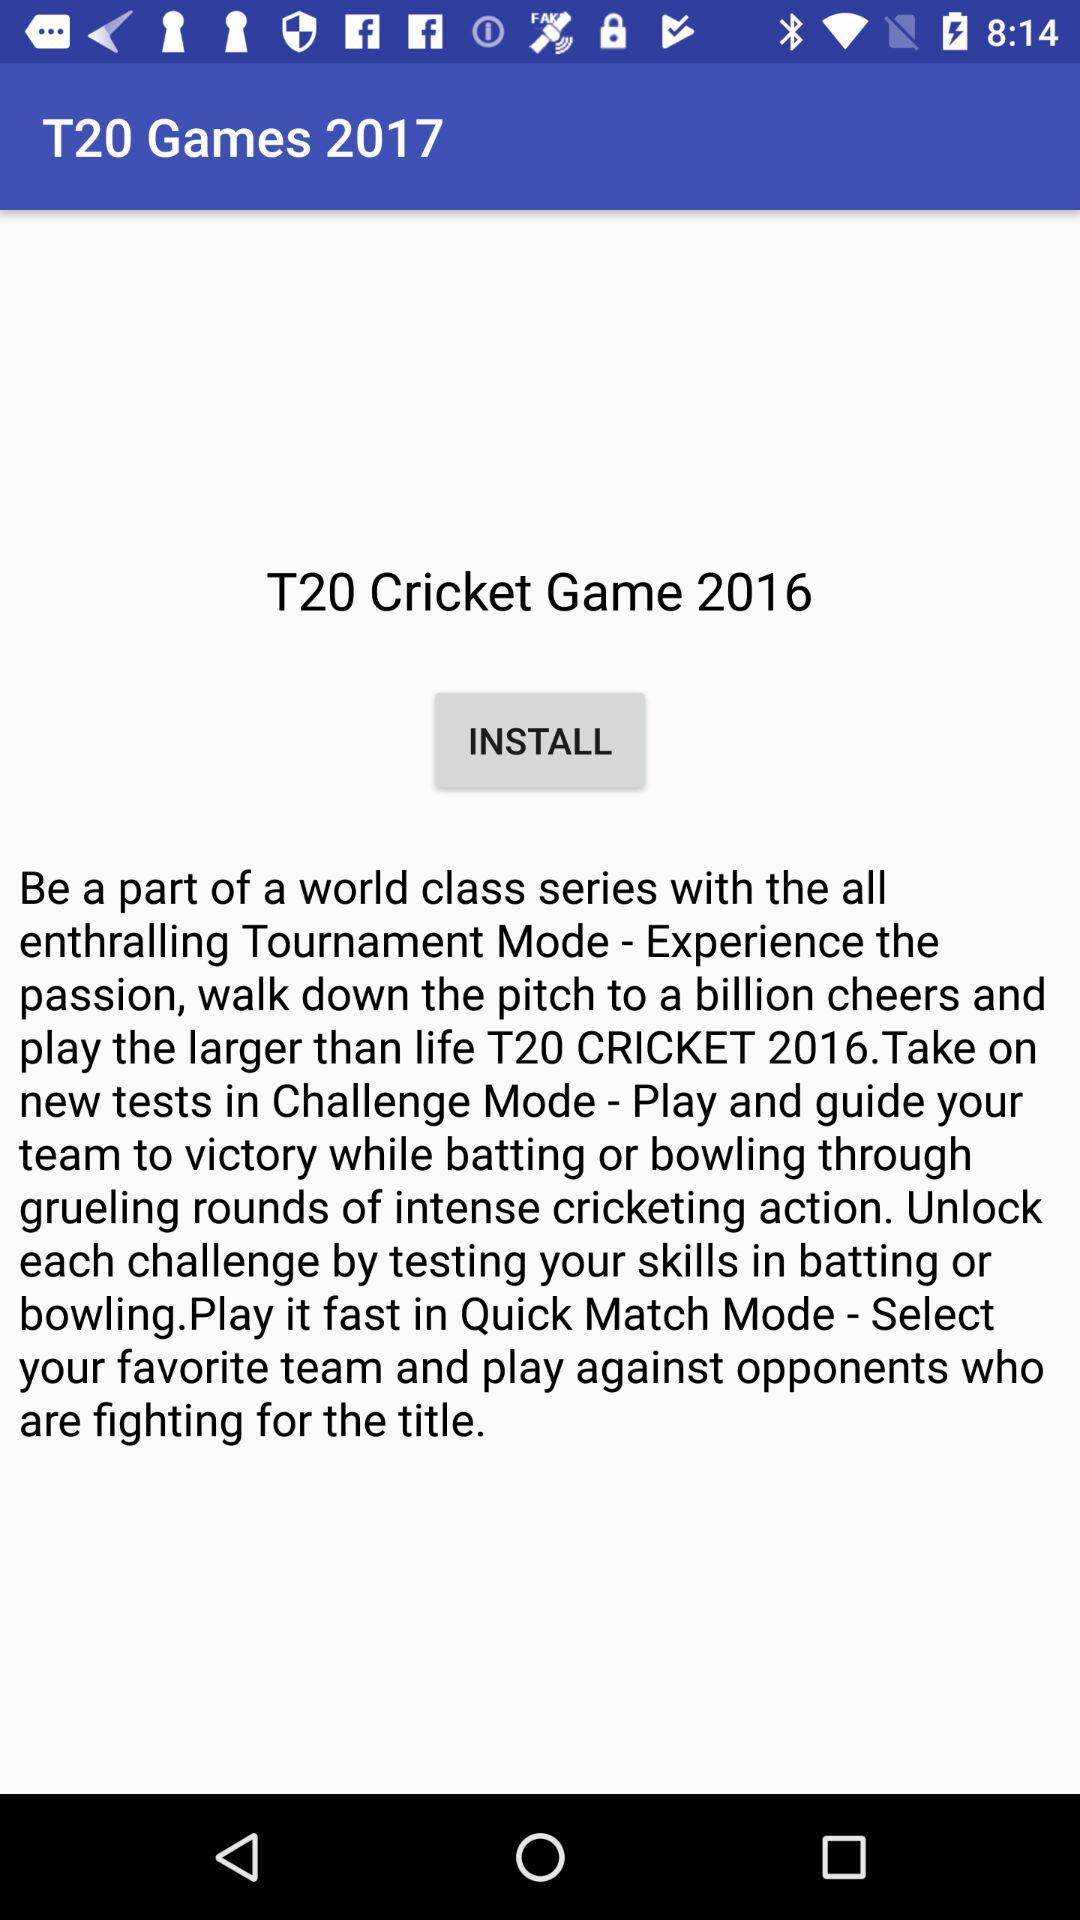What is the name of the game shown? The name of the game is "T20 Cricket Game 2016". 